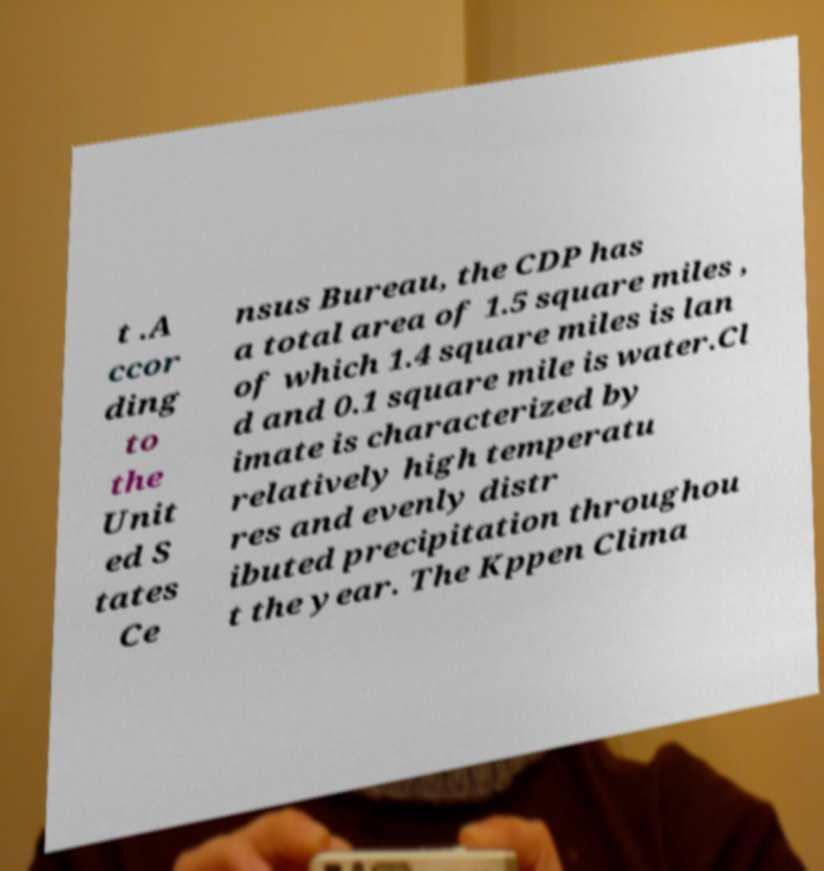Please read and relay the text visible in this image. What does it say? t .A ccor ding to the Unit ed S tates Ce nsus Bureau, the CDP has a total area of 1.5 square miles , of which 1.4 square miles is lan d and 0.1 square mile is water.Cl imate is characterized by relatively high temperatu res and evenly distr ibuted precipitation throughou t the year. The Kppen Clima 